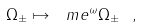Convert formula to latex. <formula><loc_0><loc_0><loc_500><loc_500>\Omega _ { \pm } \mapsto \ m e ^ { \omega } \Omega _ { \pm } \ ,</formula> 